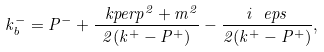Convert formula to latex. <formula><loc_0><loc_0><loc_500><loc_500>k _ { b } ^ { - } = P ^ { - } + \frac { \ k p e r p ^ { 2 } + m ^ { 2 } } { 2 ( k ^ { + } - P ^ { + } ) } - \frac { i \ e p s } { 2 ( k ^ { + } - P ^ { + } ) } ,</formula> 